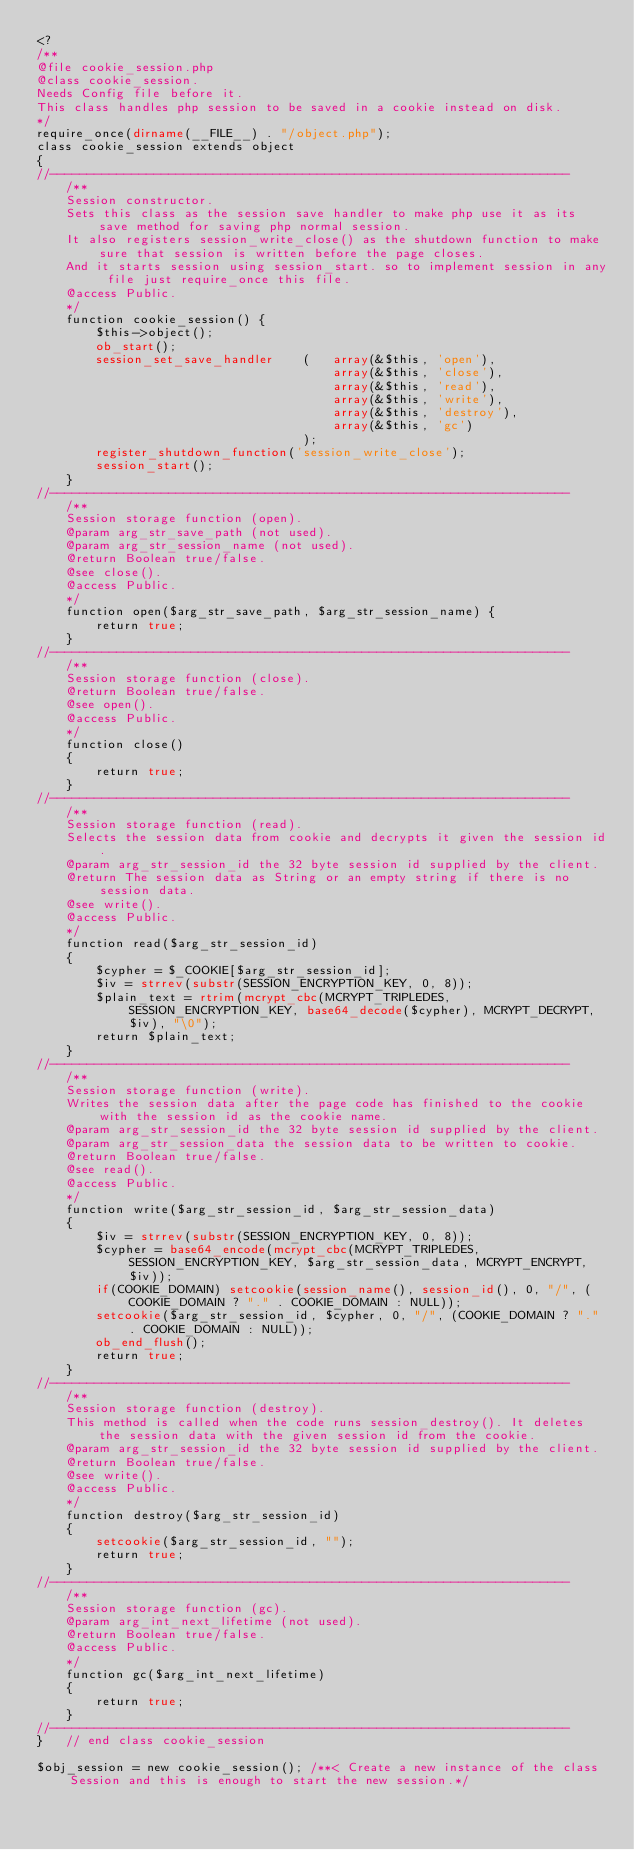Convert code to text. <code><loc_0><loc_0><loc_500><loc_500><_PHP_><?
/**
@file cookie_session.php
@class cookie_session.
Needs Config file before it.
This class handles php session to be saved in a cookie instead on disk.
*/
require_once(dirname(__FILE__) . "/object.php");
class cookie_session extends object
{
//----------------------------------------------------------------------
	/**
	Session constructor.
	Sets this class as the session save handler to make php use it as its save method for saving php normal session.
	It also registers session_write_close() as the shutdown function to make sure that session is written before the page closes.
	And it starts session using session_start. so to implement session in any file just require_once this file.
	@access Public.
	*/
	function cookie_session() {
		$this->object();
		ob_start();
		session_set_save_handler	(	array(&$this, 'open'),
										array(&$this, 'close'),
										array(&$this, 'read'),
										array(&$this, 'write'),
										array(&$this, 'destroy'),
										array(&$this, 'gc')
									);
		register_shutdown_function('session_write_close');
		session_start();
	}
//----------------------------------------------------------------------
	/**
	Session storage function (open).
	@param arg_str_save_path (not used).
	@param arg_str_session_name (not used).
	@return Boolean true/false.
	@see close().
	@access Public.
	*/
	function open($arg_str_save_path, $arg_str_session_name) {
		return true;
	}
//----------------------------------------------------------------------
	/**
	Session storage function (close).
	@return Boolean true/false.
	@see open().
	@access Public.
	*/
	function close() 
	{
		return true;
	}
//----------------------------------------------------------------------
	/**
	Session storage function (read).
	Selects the session data from cookie and decrypts it given the session id.
	@param arg_str_session_id the 32 byte session id supplied by the client.
	@return The session data as String or an empty string if there is no session data.
	@see write().
	@access Public.
	*/	
	function read($arg_str_session_id) 
	{
		$cypher = $_COOKIE[$arg_str_session_id];
		$iv = strrev(substr(SESSION_ENCRYPTION_KEY, 0, 8));
		$plain_text = rtrim(mcrypt_cbc(MCRYPT_TRIPLEDES, SESSION_ENCRYPTION_KEY, base64_decode($cypher), MCRYPT_DECRYPT, $iv), "\0");
		return $plain_text;
	}
//----------------------------------------------------------------------
	/**
	Session storage function (write).
	Writes the session data after the page code has finished to the cookie with the session id as the cookie name.
	@param arg_str_session_id the 32 byte session id supplied by the client.
	@param arg_str_session_data the session data to be written to cookie.
	@return Boolean true/false.
	@see read().
	@access Public.
	*/	
	function write($arg_str_session_id, $arg_str_session_data) 
	{
		$iv = strrev(substr(SESSION_ENCRYPTION_KEY, 0, 8));
		$cypher = base64_encode(mcrypt_cbc(MCRYPT_TRIPLEDES, SESSION_ENCRYPTION_KEY, $arg_str_session_data, MCRYPT_ENCRYPT, $iv));
		if(COOKIE_DOMAIN) setcookie(session_name(), session_id(), 0, "/", (COOKIE_DOMAIN ? "." . COOKIE_DOMAIN : NULL));
		setcookie($arg_str_session_id, $cypher, 0, "/", (COOKIE_DOMAIN ? "." . COOKIE_DOMAIN : NULL));
		ob_end_flush();
		return true;
	}
//----------------------------------------------------------------------
	/**
	Session storage function (destroy).
	This method is called when the code runs session_destroy(). It deletes the session data with the given session id from the cookie.
	@param arg_str_session_id the 32 byte session id supplied by the client.
	@return Boolean true/false.
	@see write().
	@access Public.
	*/	
	function destroy($arg_str_session_id) 
	{
		setcookie($arg_str_session_id, "");
		return true;
	}
//----------------------------------------------------------------------	
	/**
	Session storage function (gc).
	@param arg_int_next_lifetime (not used).
	@return Boolean true/false.
	@access Public.
	*/
	function gc($arg_int_next_lifetime) 
	{
		return true;
	}
//----------------------------------------------------------------------
}	// end class cookie_session

$obj_session = new cookie_session(); /**< Create a new instance of the class Session and this is enough to start the new session.*/

</code> 